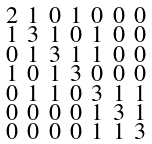<formula> <loc_0><loc_0><loc_500><loc_500>\begin{smallmatrix} 2 & 1 & 0 & 1 & 0 & 0 & 0 \\ 1 & 3 & 1 & 0 & 1 & 0 & 0 \\ 0 & 1 & 3 & 1 & 1 & 0 & 0 \\ 1 & 0 & 1 & 3 & 0 & 0 & 0 \\ 0 & 1 & 1 & 0 & 3 & 1 & 1 \\ 0 & 0 & 0 & 0 & 1 & 3 & 1 \\ 0 & 0 & 0 & 0 & 1 & 1 & 3 \end{smallmatrix}</formula> 